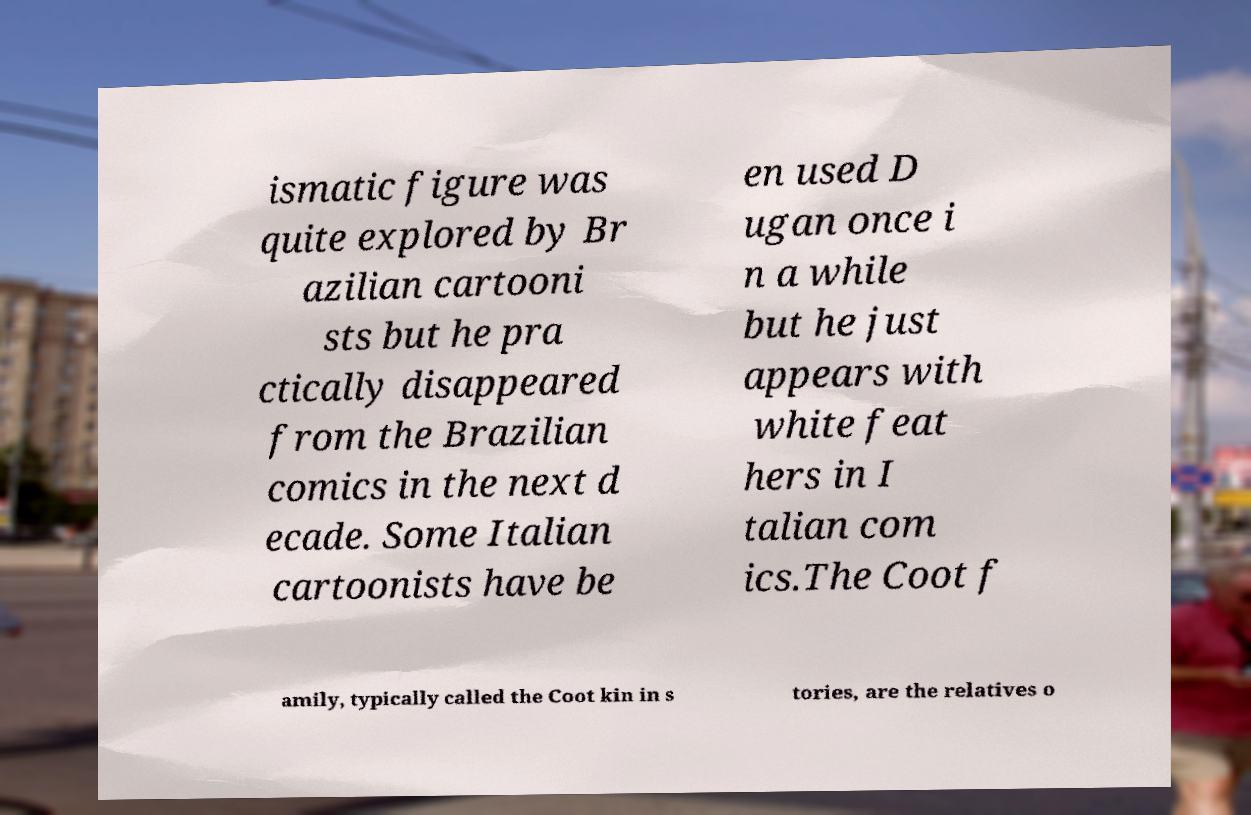Can you read and provide the text displayed in the image?This photo seems to have some interesting text. Can you extract and type it out for me? ismatic figure was quite explored by Br azilian cartooni sts but he pra ctically disappeared from the Brazilian comics in the next d ecade. Some Italian cartoonists have be en used D ugan once i n a while but he just appears with white feat hers in I talian com ics.The Coot f amily, typically called the Coot kin in s tories, are the relatives o 